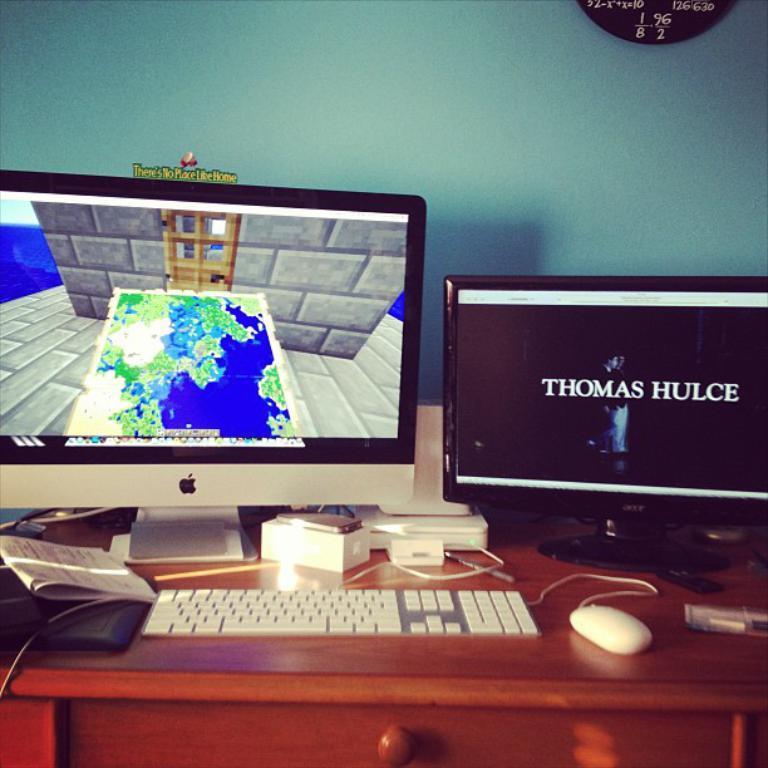Could you give a brief overview of what you see in this image? In this image I can see there is the Macbook on the left side. At the bottom there is the keyboard and a mouse. On the right side there is the desktop. 